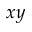Convert formula to latex. <formula><loc_0><loc_0><loc_500><loc_500>x y</formula> 